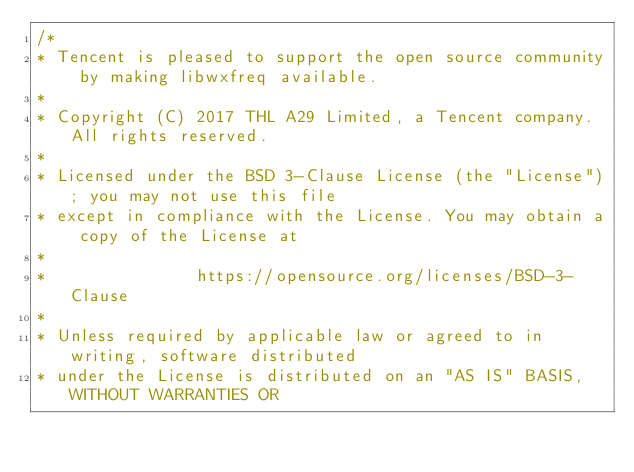<code> <loc_0><loc_0><loc_500><loc_500><_C++_>/*
* Tencent is pleased to support the open source community by making libwxfreq available.
*
* Copyright (C) 2017 THL A29 Limited, a Tencent company. All rights reserved.
*
* Licensed under the BSD 3-Clause License (the "License"); you may not use this file
* except in compliance with the License. You may obtain a copy of the License at
*
*               https://opensource.org/licenses/BSD-3-Clause
*
* Unless required by applicable law or agreed to in writing, software distributed
* under the License is distributed on an "AS IS" BASIS, WITHOUT WARRANTIES OR</code> 